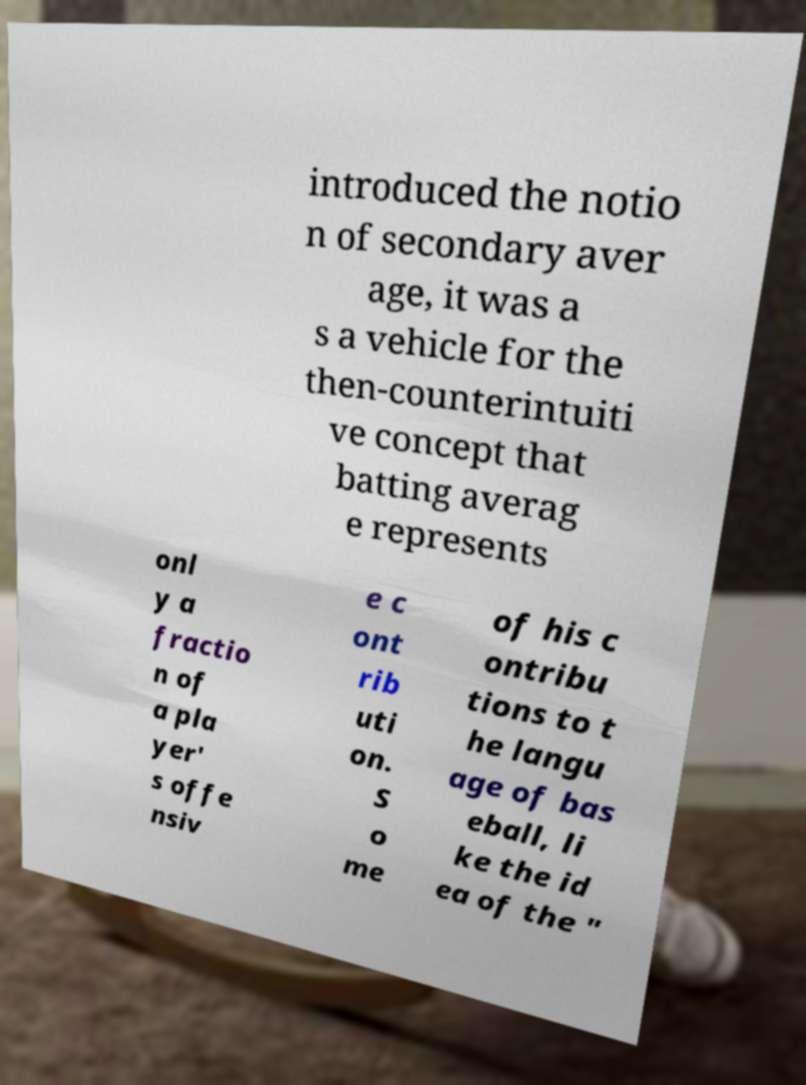What messages or text are displayed in this image? I need them in a readable, typed format. introduced the notio n of secondary aver age, it was a s a vehicle for the then-counterintuiti ve concept that batting averag e represents onl y a fractio n of a pla yer' s offe nsiv e c ont rib uti on. S o me of his c ontribu tions to t he langu age of bas eball, li ke the id ea of the " 